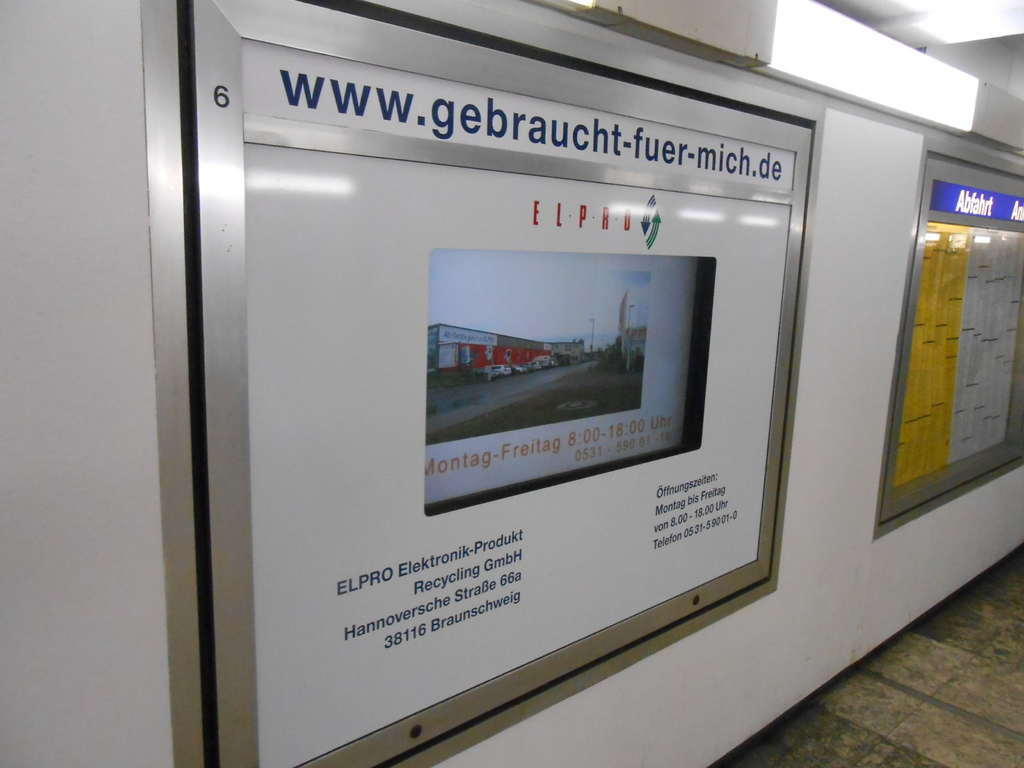What is going on in this image? Give me a detailed description. The image shows an advertisement located in a public transportation hub, possibly a subway or train station. The advertisement is for ELPRO Elektronik-Produkt Recycling GmbH, a company based in Hanover at Recycling Strasse 666, specializing in electronics recycling. The ad displays a contact number and operational hours (Monday to Friday, 8:00-18:00), suggesting that they cater to a local clientele during standard business hours. The website URL 'www.gebraucht-fuer-mich.de' is prominently displayed, indicating online engagement options. The frame of the ad is industrial-themed, supporting the recycling theme by its simple, straightforward design. 